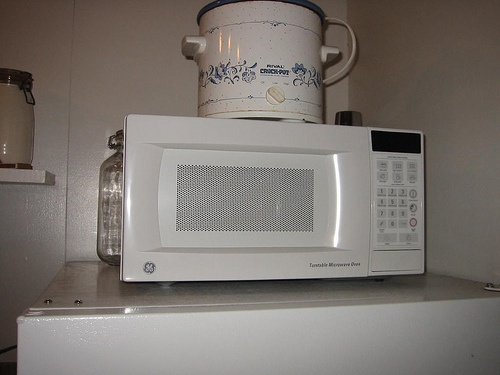Describe the objects in this image and their specific colors. I can see microwave in black, darkgray, and gray tones, refrigerator in black, darkgray, and gray tones, and bottle in black, gray, and darkgray tones in this image. 